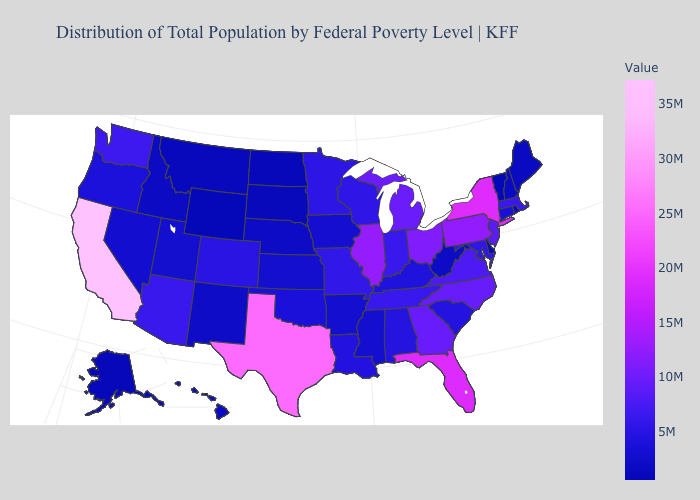Among the states that border North Carolina , which have the highest value?
Quick response, please. Georgia. Which states have the highest value in the USA?
Keep it brief. California. Does Oregon have the highest value in the West?
Answer briefly. No. Does Oregon have a lower value than Texas?
Concise answer only. Yes. Does Wyoming have the lowest value in the USA?
Be succinct. Yes. 